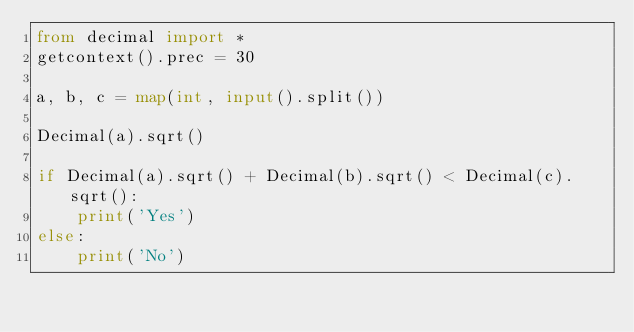<code> <loc_0><loc_0><loc_500><loc_500><_Python_>from decimal import *
getcontext().prec = 30

a, b, c = map(int, input().split())

Decimal(a).sqrt()

if Decimal(a).sqrt() + Decimal(b).sqrt() < Decimal(c).sqrt():
    print('Yes')
else:
    print('No')
</code> 